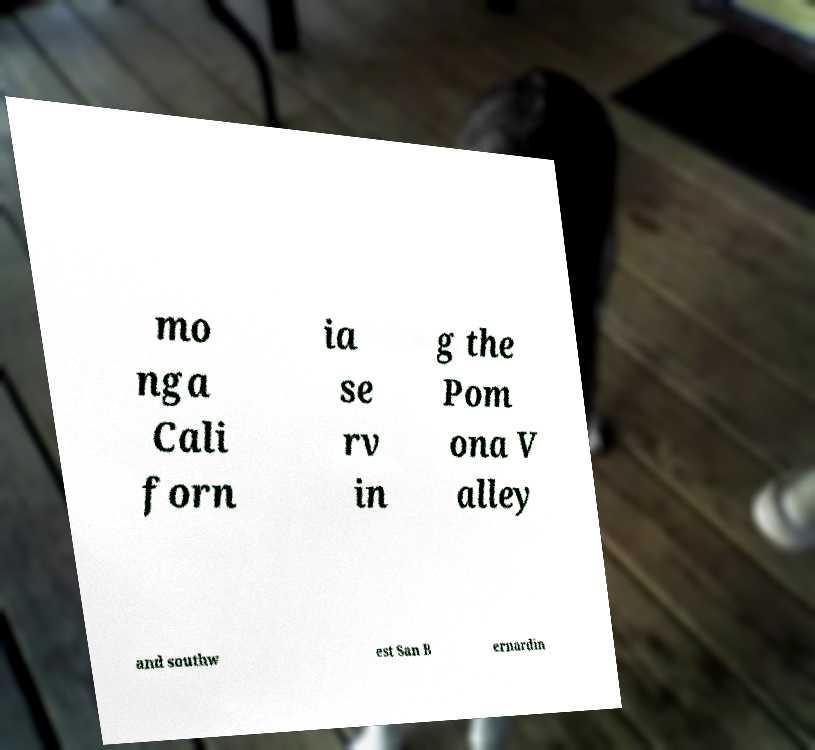Please identify and transcribe the text found in this image. mo nga Cali forn ia se rv in g the Pom ona V alley and southw est San B ernardin 